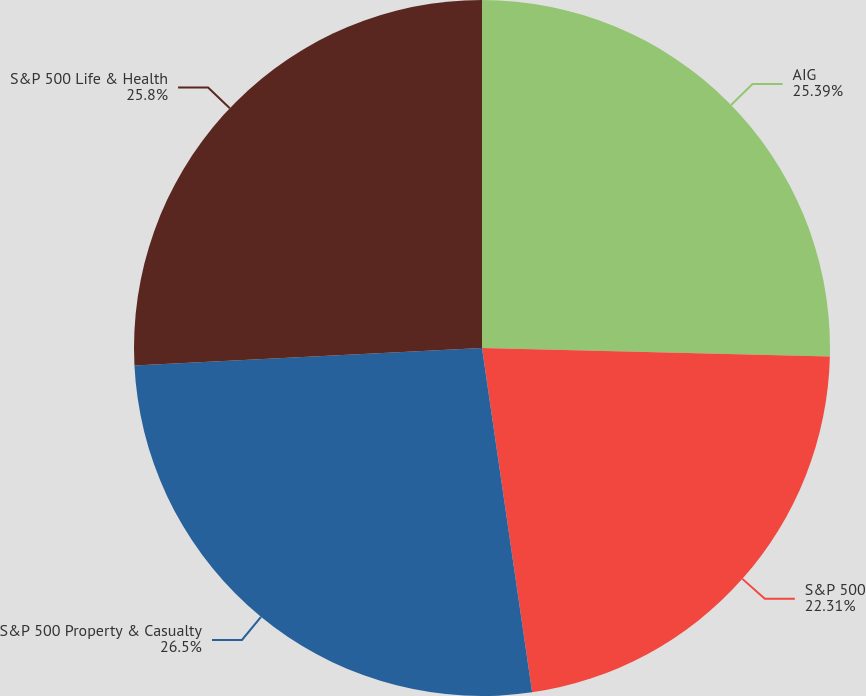Convert chart to OTSL. <chart><loc_0><loc_0><loc_500><loc_500><pie_chart><fcel>AIG<fcel>S&P 500<fcel>S&P 500 Property & Casualty<fcel>S&P 500 Life & Health<nl><fcel>25.39%<fcel>22.31%<fcel>26.5%<fcel>25.8%<nl></chart> 